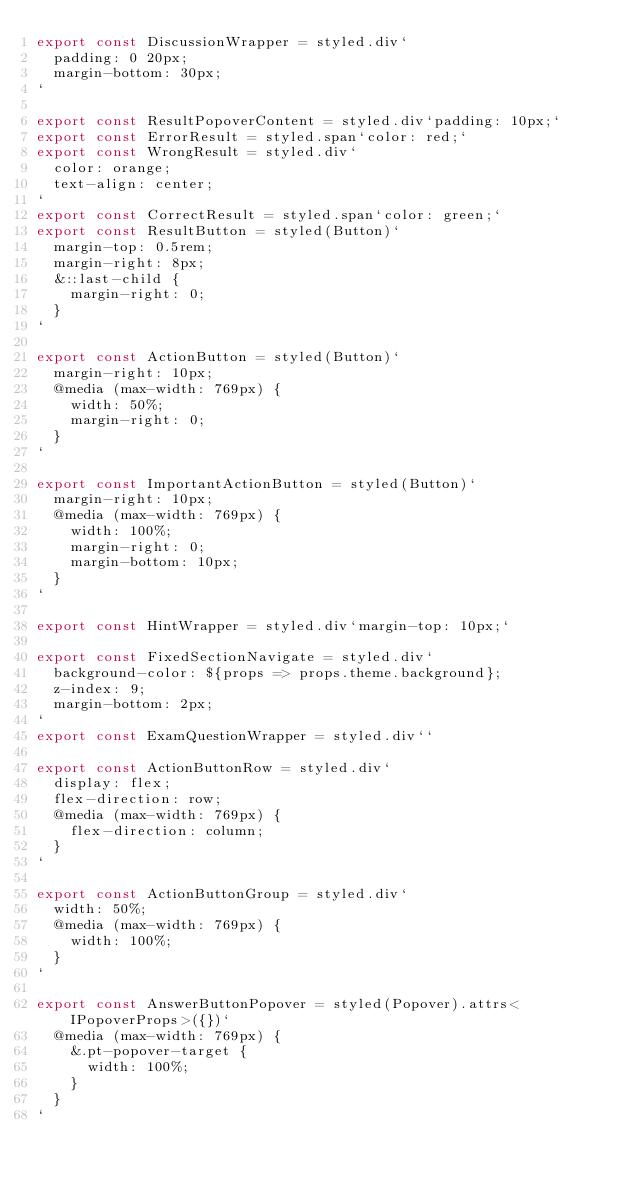<code> <loc_0><loc_0><loc_500><loc_500><_TypeScript_>export const DiscussionWrapper = styled.div`
  padding: 0 20px;
  margin-bottom: 30px;
`

export const ResultPopoverContent = styled.div`padding: 10px;`
export const ErrorResult = styled.span`color: red;`
export const WrongResult = styled.div`
  color: orange;
  text-align: center;
`
export const CorrectResult = styled.span`color: green;`
export const ResultButton = styled(Button)`
  margin-top: 0.5rem;
  margin-right: 8px;
  &::last-child {
    margin-right: 0;
  }
`

export const ActionButton = styled(Button)`
  margin-right: 10px;
  @media (max-width: 769px) {
    width: 50%;
    margin-right: 0;
  }
`

export const ImportantActionButton = styled(Button)`
  margin-right: 10px;
  @media (max-width: 769px) {
    width: 100%;
    margin-right: 0;
    margin-bottom: 10px;
  }
`

export const HintWrapper = styled.div`margin-top: 10px;`

export const FixedSectionNavigate = styled.div`
  background-color: ${props => props.theme.background};
  z-index: 9;
  margin-bottom: 2px;
`
export const ExamQuestionWrapper = styled.div``

export const ActionButtonRow = styled.div`
  display: flex;
  flex-direction: row;
  @media (max-width: 769px) {
    flex-direction: column;
  }
`

export const ActionButtonGroup = styled.div`
  width: 50%;
  @media (max-width: 769px) {
    width: 100%;
  }
`

export const AnswerButtonPopover = styled(Popover).attrs<IPopoverProps>({})`
  @media (max-width: 769px) {
    &.pt-popover-target {
      width: 100%;
    }
  }
`
</code> 